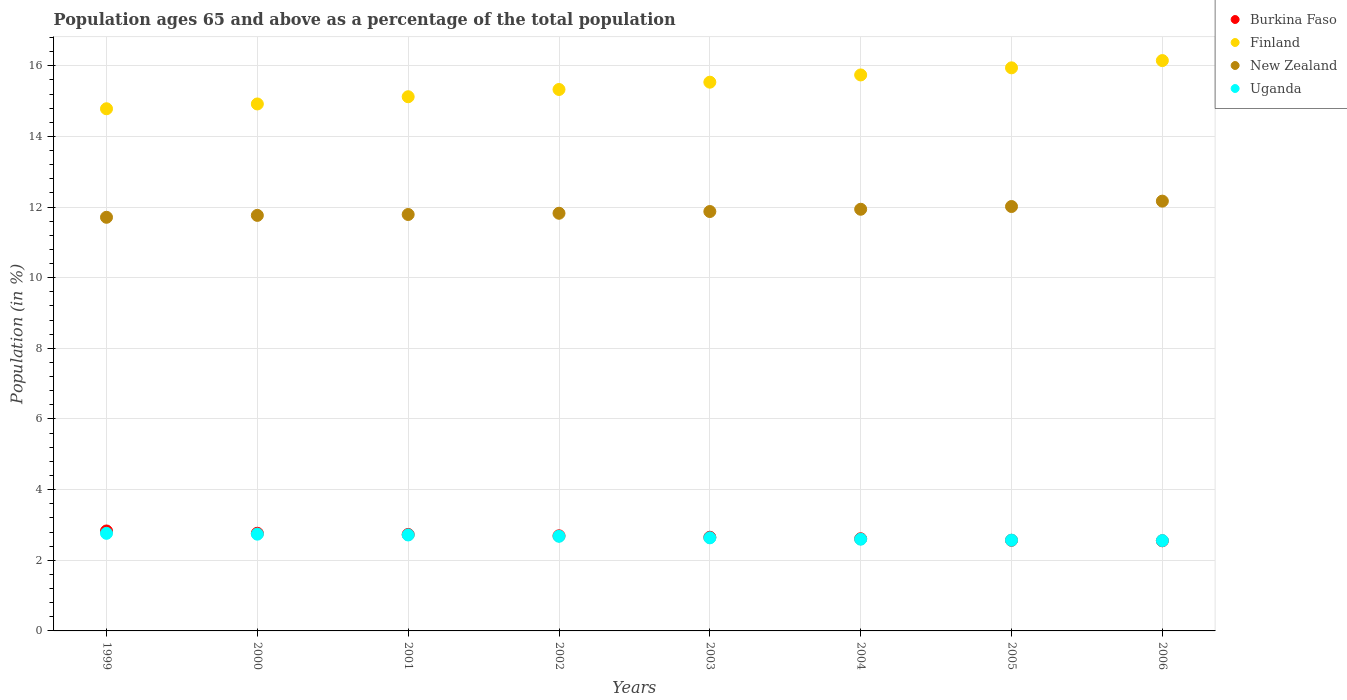How many different coloured dotlines are there?
Ensure brevity in your answer.  4. What is the percentage of the population ages 65 and above in Finland in 2003?
Make the answer very short. 15.54. Across all years, what is the maximum percentage of the population ages 65 and above in New Zealand?
Give a very brief answer. 12.17. Across all years, what is the minimum percentage of the population ages 65 and above in Burkina Faso?
Provide a succinct answer. 2.55. In which year was the percentage of the population ages 65 and above in Uganda maximum?
Keep it short and to the point. 1999. What is the total percentage of the population ages 65 and above in Burkina Faso in the graph?
Make the answer very short. 21.4. What is the difference between the percentage of the population ages 65 and above in New Zealand in 2002 and that in 2003?
Offer a very short reply. -0.05. What is the difference between the percentage of the population ages 65 and above in Burkina Faso in 1999 and the percentage of the population ages 65 and above in New Zealand in 2000?
Give a very brief answer. -8.93. What is the average percentage of the population ages 65 and above in Finland per year?
Provide a short and direct response. 15.44. In the year 2001, what is the difference between the percentage of the population ages 65 and above in Burkina Faso and percentage of the population ages 65 and above in Finland?
Provide a succinct answer. -12.39. In how many years, is the percentage of the population ages 65 and above in Finland greater than 7.2?
Offer a very short reply. 8. What is the ratio of the percentage of the population ages 65 and above in Finland in 2003 to that in 2006?
Keep it short and to the point. 0.96. Is the difference between the percentage of the population ages 65 and above in Burkina Faso in 2003 and 2005 greater than the difference between the percentage of the population ages 65 and above in Finland in 2003 and 2005?
Give a very brief answer. Yes. What is the difference between the highest and the second highest percentage of the population ages 65 and above in Finland?
Provide a succinct answer. 0.21. What is the difference between the highest and the lowest percentage of the population ages 65 and above in New Zealand?
Your response must be concise. 0.46. Is the sum of the percentage of the population ages 65 and above in Finland in 1999 and 2003 greater than the maximum percentage of the population ages 65 and above in New Zealand across all years?
Make the answer very short. Yes. Does the percentage of the population ages 65 and above in Finland monotonically increase over the years?
Your answer should be very brief. Yes. Is the percentage of the population ages 65 and above in New Zealand strictly less than the percentage of the population ages 65 and above in Uganda over the years?
Offer a very short reply. No. How many dotlines are there?
Provide a succinct answer. 4. Are the values on the major ticks of Y-axis written in scientific E-notation?
Keep it short and to the point. No. Does the graph contain grids?
Give a very brief answer. Yes. How many legend labels are there?
Provide a succinct answer. 4. What is the title of the graph?
Offer a terse response. Population ages 65 and above as a percentage of the total population. What is the Population (in %) of Burkina Faso in 1999?
Your answer should be very brief. 2.83. What is the Population (in %) of Finland in 1999?
Offer a terse response. 14.78. What is the Population (in %) in New Zealand in 1999?
Give a very brief answer. 11.71. What is the Population (in %) of Uganda in 1999?
Offer a terse response. 2.76. What is the Population (in %) of Burkina Faso in 2000?
Ensure brevity in your answer.  2.76. What is the Population (in %) of Finland in 2000?
Your response must be concise. 14.92. What is the Population (in %) of New Zealand in 2000?
Keep it short and to the point. 11.76. What is the Population (in %) of Uganda in 2000?
Your answer should be compact. 2.74. What is the Population (in %) in Burkina Faso in 2001?
Keep it short and to the point. 2.73. What is the Population (in %) in Finland in 2001?
Your response must be concise. 15.12. What is the Population (in %) of New Zealand in 2001?
Ensure brevity in your answer.  11.79. What is the Population (in %) in Uganda in 2001?
Make the answer very short. 2.72. What is the Population (in %) of Burkina Faso in 2002?
Offer a terse response. 2.69. What is the Population (in %) in Finland in 2002?
Keep it short and to the point. 15.33. What is the Population (in %) in New Zealand in 2002?
Offer a very short reply. 11.82. What is the Population (in %) of Uganda in 2002?
Keep it short and to the point. 2.68. What is the Population (in %) in Burkina Faso in 2003?
Your answer should be very brief. 2.65. What is the Population (in %) in Finland in 2003?
Offer a very short reply. 15.54. What is the Population (in %) in New Zealand in 2003?
Offer a very short reply. 11.87. What is the Population (in %) of Uganda in 2003?
Offer a very short reply. 2.64. What is the Population (in %) in Burkina Faso in 2004?
Provide a succinct answer. 2.61. What is the Population (in %) of Finland in 2004?
Provide a short and direct response. 15.74. What is the Population (in %) in New Zealand in 2004?
Give a very brief answer. 11.94. What is the Population (in %) of Uganda in 2004?
Your response must be concise. 2.6. What is the Population (in %) in Burkina Faso in 2005?
Ensure brevity in your answer.  2.57. What is the Population (in %) in Finland in 2005?
Keep it short and to the point. 15.94. What is the Population (in %) of New Zealand in 2005?
Your answer should be compact. 12.02. What is the Population (in %) of Uganda in 2005?
Keep it short and to the point. 2.57. What is the Population (in %) of Burkina Faso in 2006?
Give a very brief answer. 2.55. What is the Population (in %) of Finland in 2006?
Your answer should be compact. 16.15. What is the Population (in %) of New Zealand in 2006?
Provide a short and direct response. 12.17. What is the Population (in %) of Uganda in 2006?
Provide a succinct answer. 2.56. Across all years, what is the maximum Population (in %) of Burkina Faso?
Ensure brevity in your answer.  2.83. Across all years, what is the maximum Population (in %) in Finland?
Offer a very short reply. 16.15. Across all years, what is the maximum Population (in %) of New Zealand?
Make the answer very short. 12.17. Across all years, what is the maximum Population (in %) in Uganda?
Offer a terse response. 2.76. Across all years, what is the minimum Population (in %) of Burkina Faso?
Make the answer very short. 2.55. Across all years, what is the minimum Population (in %) in Finland?
Keep it short and to the point. 14.78. Across all years, what is the minimum Population (in %) of New Zealand?
Your answer should be compact. 11.71. Across all years, what is the minimum Population (in %) of Uganda?
Your answer should be very brief. 2.56. What is the total Population (in %) of Burkina Faso in the graph?
Offer a very short reply. 21.4. What is the total Population (in %) in Finland in the graph?
Your answer should be compact. 123.52. What is the total Population (in %) of New Zealand in the graph?
Your answer should be very brief. 95.08. What is the total Population (in %) of Uganda in the graph?
Give a very brief answer. 21.26. What is the difference between the Population (in %) in Burkina Faso in 1999 and that in 2000?
Your answer should be very brief. 0.06. What is the difference between the Population (in %) of Finland in 1999 and that in 2000?
Give a very brief answer. -0.14. What is the difference between the Population (in %) of New Zealand in 1999 and that in 2000?
Your answer should be compact. -0.05. What is the difference between the Population (in %) of Uganda in 1999 and that in 2000?
Keep it short and to the point. 0.02. What is the difference between the Population (in %) of Burkina Faso in 1999 and that in 2001?
Offer a terse response. 0.1. What is the difference between the Population (in %) of Finland in 1999 and that in 2001?
Offer a very short reply. -0.34. What is the difference between the Population (in %) of New Zealand in 1999 and that in 2001?
Ensure brevity in your answer.  -0.08. What is the difference between the Population (in %) of Uganda in 1999 and that in 2001?
Keep it short and to the point. 0.05. What is the difference between the Population (in %) in Burkina Faso in 1999 and that in 2002?
Offer a terse response. 0.14. What is the difference between the Population (in %) in Finland in 1999 and that in 2002?
Your answer should be very brief. -0.55. What is the difference between the Population (in %) in New Zealand in 1999 and that in 2002?
Ensure brevity in your answer.  -0.11. What is the difference between the Population (in %) of Uganda in 1999 and that in 2002?
Keep it short and to the point. 0.08. What is the difference between the Population (in %) in Burkina Faso in 1999 and that in 2003?
Provide a succinct answer. 0.18. What is the difference between the Population (in %) in Finland in 1999 and that in 2003?
Provide a short and direct response. -0.75. What is the difference between the Population (in %) of New Zealand in 1999 and that in 2003?
Ensure brevity in your answer.  -0.16. What is the difference between the Population (in %) in Uganda in 1999 and that in 2003?
Ensure brevity in your answer.  0.13. What is the difference between the Population (in %) of Burkina Faso in 1999 and that in 2004?
Keep it short and to the point. 0.22. What is the difference between the Population (in %) in Finland in 1999 and that in 2004?
Provide a short and direct response. -0.96. What is the difference between the Population (in %) in New Zealand in 1999 and that in 2004?
Keep it short and to the point. -0.23. What is the difference between the Population (in %) in Uganda in 1999 and that in 2004?
Your answer should be compact. 0.17. What is the difference between the Population (in %) of Burkina Faso in 1999 and that in 2005?
Make the answer very short. 0.26. What is the difference between the Population (in %) of Finland in 1999 and that in 2005?
Your response must be concise. -1.16. What is the difference between the Population (in %) in New Zealand in 1999 and that in 2005?
Make the answer very short. -0.3. What is the difference between the Population (in %) of Uganda in 1999 and that in 2005?
Your answer should be compact. 0.19. What is the difference between the Population (in %) of Burkina Faso in 1999 and that in 2006?
Your response must be concise. 0.28. What is the difference between the Population (in %) of Finland in 1999 and that in 2006?
Your response must be concise. -1.36. What is the difference between the Population (in %) of New Zealand in 1999 and that in 2006?
Provide a succinct answer. -0.46. What is the difference between the Population (in %) in Uganda in 1999 and that in 2006?
Offer a very short reply. 0.21. What is the difference between the Population (in %) of Burkina Faso in 2000 and that in 2001?
Offer a very short reply. 0.03. What is the difference between the Population (in %) of Finland in 2000 and that in 2001?
Your response must be concise. -0.2. What is the difference between the Population (in %) of New Zealand in 2000 and that in 2001?
Your response must be concise. -0.03. What is the difference between the Population (in %) of Uganda in 2000 and that in 2001?
Keep it short and to the point. 0.02. What is the difference between the Population (in %) of Burkina Faso in 2000 and that in 2002?
Your answer should be very brief. 0.07. What is the difference between the Population (in %) in Finland in 2000 and that in 2002?
Give a very brief answer. -0.41. What is the difference between the Population (in %) of New Zealand in 2000 and that in 2002?
Give a very brief answer. -0.06. What is the difference between the Population (in %) in Uganda in 2000 and that in 2002?
Keep it short and to the point. 0.06. What is the difference between the Population (in %) of Burkina Faso in 2000 and that in 2003?
Give a very brief answer. 0.11. What is the difference between the Population (in %) in Finland in 2000 and that in 2003?
Provide a short and direct response. -0.62. What is the difference between the Population (in %) in New Zealand in 2000 and that in 2003?
Make the answer very short. -0.11. What is the difference between the Population (in %) in Uganda in 2000 and that in 2003?
Your answer should be compact. 0.1. What is the difference between the Population (in %) of Burkina Faso in 2000 and that in 2004?
Keep it short and to the point. 0.16. What is the difference between the Population (in %) of Finland in 2000 and that in 2004?
Ensure brevity in your answer.  -0.82. What is the difference between the Population (in %) of New Zealand in 2000 and that in 2004?
Your answer should be very brief. -0.17. What is the difference between the Population (in %) of Uganda in 2000 and that in 2004?
Your response must be concise. 0.14. What is the difference between the Population (in %) in Burkina Faso in 2000 and that in 2005?
Provide a short and direct response. 0.2. What is the difference between the Population (in %) of Finland in 2000 and that in 2005?
Provide a succinct answer. -1.02. What is the difference between the Population (in %) of New Zealand in 2000 and that in 2005?
Ensure brevity in your answer.  -0.25. What is the difference between the Population (in %) in Uganda in 2000 and that in 2005?
Offer a very short reply. 0.17. What is the difference between the Population (in %) of Burkina Faso in 2000 and that in 2006?
Ensure brevity in your answer.  0.21. What is the difference between the Population (in %) in Finland in 2000 and that in 2006?
Offer a very short reply. -1.23. What is the difference between the Population (in %) of New Zealand in 2000 and that in 2006?
Offer a terse response. -0.4. What is the difference between the Population (in %) in Uganda in 2000 and that in 2006?
Offer a terse response. 0.18. What is the difference between the Population (in %) of Burkina Faso in 2001 and that in 2002?
Make the answer very short. 0.04. What is the difference between the Population (in %) of Finland in 2001 and that in 2002?
Your response must be concise. -0.21. What is the difference between the Population (in %) in New Zealand in 2001 and that in 2002?
Your answer should be very brief. -0.03. What is the difference between the Population (in %) of Uganda in 2001 and that in 2002?
Keep it short and to the point. 0.04. What is the difference between the Population (in %) in Burkina Faso in 2001 and that in 2003?
Make the answer very short. 0.08. What is the difference between the Population (in %) in Finland in 2001 and that in 2003?
Your answer should be very brief. -0.41. What is the difference between the Population (in %) of New Zealand in 2001 and that in 2003?
Offer a terse response. -0.08. What is the difference between the Population (in %) in Uganda in 2001 and that in 2003?
Your answer should be compact. 0.08. What is the difference between the Population (in %) in Burkina Faso in 2001 and that in 2004?
Offer a very short reply. 0.12. What is the difference between the Population (in %) in Finland in 2001 and that in 2004?
Your response must be concise. -0.62. What is the difference between the Population (in %) of New Zealand in 2001 and that in 2004?
Your answer should be very brief. -0.15. What is the difference between the Population (in %) in Uganda in 2001 and that in 2004?
Offer a very short reply. 0.12. What is the difference between the Population (in %) in Burkina Faso in 2001 and that in 2005?
Offer a very short reply. 0.16. What is the difference between the Population (in %) in Finland in 2001 and that in 2005?
Your answer should be very brief. -0.82. What is the difference between the Population (in %) of New Zealand in 2001 and that in 2005?
Keep it short and to the point. -0.23. What is the difference between the Population (in %) in Uganda in 2001 and that in 2005?
Give a very brief answer. 0.15. What is the difference between the Population (in %) in Burkina Faso in 2001 and that in 2006?
Your answer should be compact. 0.18. What is the difference between the Population (in %) of Finland in 2001 and that in 2006?
Your answer should be very brief. -1.02. What is the difference between the Population (in %) of New Zealand in 2001 and that in 2006?
Make the answer very short. -0.38. What is the difference between the Population (in %) of Uganda in 2001 and that in 2006?
Offer a very short reply. 0.16. What is the difference between the Population (in %) of Burkina Faso in 2002 and that in 2003?
Make the answer very short. 0.04. What is the difference between the Population (in %) in Finland in 2002 and that in 2003?
Make the answer very short. -0.21. What is the difference between the Population (in %) of New Zealand in 2002 and that in 2003?
Provide a succinct answer. -0.05. What is the difference between the Population (in %) in Uganda in 2002 and that in 2003?
Keep it short and to the point. 0.04. What is the difference between the Population (in %) in Burkina Faso in 2002 and that in 2004?
Your answer should be compact. 0.08. What is the difference between the Population (in %) in Finland in 2002 and that in 2004?
Your answer should be compact. -0.41. What is the difference between the Population (in %) in New Zealand in 2002 and that in 2004?
Your response must be concise. -0.11. What is the difference between the Population (in %) in Uganda in 2002 and that in 2004?
Provide a short and direct response. 0.08. What is the difference between the Population (in %) in Burkina Faso in 2002 and that in 2005?
Provide a short and direct response. 0.13. What is the difference between the Population (in %) in Finland in 2002 and that in 2005?
Your answer should be very brief. -0.61. What is the difference between the Population (in %) in New Zealand in 2002 and that in 2005?
Offer a very short reply. -0.19. What is the difference between the Population (in %) in Uganda in 2002 and that in 2005?
Your answer should be compact. 0.11. What is the difference between the Population (in %) in Burkina Faso in 2002 and that in 2006?
Offer a very short reply. 0.14. What is the difference between the Population (in %) in Finland in 2002 and that in 2006?
Give a very brief answer. -0.82. What is the difference between the Population (in %) of New Zealand in 2002 and that in 2006?
Provide a succinct answer. -0.34. What is the difference between the Population (in %) of Uganda in 2002 and that in 2006?
Your answer should be very brief. 0.12. What is the difference between the Population (in %) in Burkina Faso in 2003 and that in 2004?
Offer a terse response. 0.04. What is the difference between the Population (in %) in Finland in 2003 and that in 2004?
Offer a very short reply. -0.2. What is the difference between the Population (in %) in New Zealand in 2003 and that in 2004?
Your answer should be compact. -0.06. What is the difference between the Population (in %) in Uganda in 2003 and that in 2004?
Your answer should be very brief. 0.04. What is the difference between the Population (in %) of Burkina Faso in 2003 and that in 2005?
Provide a succinct answer. 0.09. What is the difference between the Population (in %) of Finland in 2003 and that in 2005?
Offer a terse response. -0.41. What is the difference between the Population (in %) in New Zealand in 2003 and that in 2005?
Your answer should be compact. -0.14. What is the difference between the Population (in %) of Uganda in 2003 and that in 2005?
Offer a very short reply. 0.07. What is the difference between the Population (in %) in Burkina Faso in 2003 and that in 2006?
Offer a very short reply. 0.1. What is the difference between the Population (in %) of Finland in 2003 and that in 2006?
Keep it short and to the point. -0.61. What is the difference between the Population (in %) in New Zealand in 2003 and that in 2006?
Your response must be concise. -0.29. What is the difference between the Population (in %) of Uganda in 2003 and that in 2006?
Offer a terse response. 0.08. What is the difference between the Population (in %) of Burkina Faso in 2004 and that in 2005?
Keep it short and to the point. 0.04. What is the difference between the Population (in %) in Finland in 2004 and that in 2005?
Keep it short and to the point. -0.2. What is the difference between the Population (in %) in New Zealand in 2004 and that in 2005?
Make the answer very short. -0.08. What is the difference between the Population (in %) of Uganda in 2004 and that in 2005?
Your answer should be very brief. 0.03. What is the difference between the Population (in %) of Burkina Faso in 2004 and that in 2006?
Offer a terse response. 0.06. What is the difference between the Population (in %) of Finland in 2004 and that in 2006?
Offer a very short reply. -0.41. What is the difference between the Population (in %) of New Zealand in 2004 and that in 2006?
Give a very brief answer. -0.23. What is the difference between the Population (in %) in Uganda in 2004 and that in 2006?
Make the answer very short. 0.04. What is the difference between the Population (in %) of Burkina Faso in 2005 and that in 2006?
Your answer should be compact. 0.01. What is the difference between the Population (in %) of Finland in 2005 and that in 2006?
Give a very brief answer. -0.21. What is the difference between the Population (in %) in New Zealand in 2005 and that in 2006?
Offer a very short reply. -0.15. What is the difference between the Population (in %) in Uganda in 2005 and that in 2006?
Your answer should be very brief. 0.01. What is the difference between the Population (in %) of Burkina Faso in 1999 and the Population (in %) of Finland in 2000?
Your answer should be compact. -12.09. What is the difference between the Population (in %) in Burkina Faso in 1999 and the Population (in %) in New Zealand in 2000?
Make the answer very short. -8.93. What is the difference between the Population (in %) of Burkina Faso in 1999 and the Population (in %) of Uganda in 2000?
Provide a succinct answer. 0.09. What is the difference between the Population (in %) in Finland in 1999 and the Population (in %) in New Zealand in 2000?
Your answer should be compact. 3.02. What is the difference between the Population (in %) of Finland in 1999 and the Population (in %) of Uganda in 2000?
Keep it short and to the point. 12.04. What is the difference between the Population (in %) in New Zealand in 1999 and the Population (in %) in Uganda in 2000?
Your answer should be very brief. 8.97. What is the difference between the Population (in %) of Burkina Faso in 1999 and the Population (in %) of Finland in 2001?
Your answer should be compact. -12.29. What is the difference between the Population (in %) of Burkina Faso in 1999 and the Population (in %) of New Zealand in 2001?
Provide a short and direct response. -8.96. What is the difference between the Population (in %) of Burkina Faso in 1999 and the Population (in %) of Uganda in 2001?
Give a very brief answer. 0.11. What is the difference between the Population (in %) in Finland in 1999 and the Population (in %) in New Zealand in 2001?
Your answer should be compact. 2.99. What is the difference between the Population (in %) of Finland in 1999 and the Population (in %) of Uganda in 2001?
Offer a terse response. 12.07. What is the difference between the Population (in %) in New Zealand in 1999 and the Population (in %) in Uganda in 2001?
Your response must be concise. 8.99. What is the difference between the Population (in %) in Burkina Faso in 1999 and the Population (in %) in Finland in 2002?
Provide a succinct answer. -12.5. What is the difference between the Population (in %) in Burkina Faso in 1999 and the Population (in %) in New Zealand in 2002?
Your response must be concise. -8.99. What is the difference between the Population (in %) in Burkina Faso in 1999 and the Population (in %) in Uganda in 2002?
Your answer should be very brief. 0.15. What is the difference between the Population (in %) of Finland in 1999 and the Population (in %) of New Zealand in 2002?
Make the answer very short. 2.96. What is the difference between the Population (in %) of Finland in 1999 and the Population (in %) of Uganda in 2002?
Offer a terse response. 12.1. What is the difference between the Population (in %) of New Zealand in 1999 and the Population (in %) of Uganda in 2002?
Offer a very short reply. 9.03. What is the difference between the Population (in %) in Burkina Faso in 1999 and the Population (in %) in Finland in 2003?
Provide a succinct answer. -12.71. What is the difference between the Population (in %) of Burkina Faso in 1999 and the Population (in %) of New Zealand in 2003?
Offer a terse response. -9.04. What is the difference between the Population (in %) of Burkina Faso in 1999 and the Population (in %) of Uganda in 2003?
Your response must be concise. 0.19. What is the difference between the Population (in %) in Finland in 1999 and the Population (in %) in New Zealand in 2003?
Offer a very short reply. 2.91. What is the difference between the Population (in %) of Finland in 1999 and the Population (in %) of Uganda in 2003?
Your answer should be compact. 12.15. What is the difference between the Population (in %) of New Zealand in 1999 and the Population (in %) of Uganda in 2003?
Ensure brevity in your answer.  9.07. What is the difference between the Population (in %) in Burkina Faso in 1999 and the Population (in %) in Finland in 2004?
Ensure brevity in your answer.  -12.91. What is the difference between the Population (in %) in Burkina Faso in 1999 and the Population (in %) in New Zealand in 2004?
Make the answer very short. -9.11. What is the difference between the Population (in %) of Burkina Faso in 1999 and the Population (in %) of Uganda in 2004?
Keep it short and to the point. 0.23. What is the difference between the Population (in %) of Finland in 1999 and the Population (in %) of New Zealand in 2004?
Ensure brevity in your answer.  2.85. What is the difference between the Population (in %) of Finland in 1999 and the Population (in %) of Uganda in 2004?
Keep it short and to the point. 12.19. What is the difference between the Population (in %) in New Zealand in 1999 and the Population (in %) in Uganda in 2004?
Provide a succinct answer. 9.11. What is the difference between the Population (in %) of Burkina Faso in 1999 and the Population (in %) of Finland in 2005?
Provide a succinct answer. -13.11. What is the difference between the Population (in %) of Burkina Faso in 1999 and the Population (in %) of New Zealand in 2005?
Keep it short and to the point. -9.19. What is the difference between the Population (in %) in Burkina Faso in 1999 and the Population (in %) in Uganda in 2005?
Offer a very short reply. 0.26. What is the difference between the Population (in %) of Finland in 1999 and the Population (in %) of New Zealand in 2005?
Offer a terse response. 2.77. What is the difference between the Population (in %) of Finland in 1999 and the Population (in %) of Uganda in 2005?
Keep it short and to the point. 12.21. What is the difference between the Population (in %) of New Zealand in 1999 and the Population (in %) of Uganda in 2005?
Keep it short and to the point. 9.14. What is the difference between the Population (in %) of Burkina Faso in 1999 and the Population (in %) of Finland in 2006?
Your answer should be very brief. -13.32. What is the difference between the Population (in %) of Burkina Faso in 1999 and the Population (in %) of New Zealand in 2006?
Your answer should be compact. -9.34. What is the difference between the Population (in %) in Burkina Faso in 1999 and the Population (in %) in Uganda in 2006?
Keep it short and to the point. 0.27. What is the difference between the Population (in %) in Finland in 1999 and the Population (in %) in New Zealand in 2006?
Keep it short and to the point. 2.62. What is the difference between the Population (in %) in Finland in 1999 and the Population (in %) in Uganda in 2006?
Provide a short and direct response. 12.23. What is the difference between the Population (in %) of New Zealand in 1999 and the Population (in %) of Uganda in 2006?
Your answer should be very brief. 9.15. What is the difference between the Population (in %) in Burkina Faso in 2000 and the Population (in %) in Finland in 2001?
Provide a short and direct response. -12.36. What is the difference between the Population (in %) of Burkina Faso in 2000 and the Population (in %) of New Zealand in 2001?
Your answer should be very brief. -9.02. What is the difference between the Population (in %) in Burkina Faso in 2000 and the Population (in %) in Uganda in 2001?
Keep it short and to the point. 0.05. What is the difference between the Population (in %) in Finland in 2000 and the Population (in %) in New Zealand in 2001?
Provide a short and direct response. 3.13. What is the difference between the Population (in %) of Finland in 2000 and the Population (in %) of Uganda in 2001?
Ensure brevity in your answer.  12.2. What is the difference between the Population (in %) in New Zealand in 2000 and the Population (in %) in Uganda in 2001?
Make the answer very short. 9.05. What is the difference between the Population (in %) in Burkina Faso in 2000 and the Population (in %) in Finland in 2002?
Your answer should be compact. -12.56. What is the difference between the Population (in %) in Burkina Faso in 2000 and the Population (in %) in New Zealand in 2002?
Make the answer very short. -9.06. What is the difference between the Population (in %) in Burkina Faso in 2000 and the Population (in %) in Uganda in 2002?
Provide a succinct answer. 0.09. What is the difference between the Population (in %) of Finland in 2000 and the Population (in %) of New Zealand in 2002?
Your answer should be compact. 3.09. What is the difference between the Population (in %) of Finland in 2000 and the Population (in %) of Uganda in 2002?
Your answer should be compact. 12.24. What is the difference between the Population (in %) of New Zealand in 2000 and the Population (in %) of Uganda in 2002?
Ensure brevity in your answer.  9.09. What is the difference between the Population (in %) of Burkina Faso in 2000 and the Population (in %) of Finland in 2003?
Offer a terse response. -12.77. What is the difference between the Population (in %) in Burkina Faso in 2000 and the Population (in %) in New Zealand in 2003?
Provide a succinct answer. -9.11. What is the difference between the Population (in %) of Burkina Faso in 2000 and the Population (in %) of Uganda in 2003?
Ensure brevity in your answer.  0.13. What is the difference between the Population (in %) of Finland in 2000 and the Population (in %) of New Zealand in 2003?
Offer a very short reply. 3.05. What is the difference between the Population (in %) in Finland in 2000 and the Population (in %) in Uganda in 2003?
Offer a terse response. 12.28. What is the difference between the Population (in %) in New Zealand in 2000 and the Population (in %) in Uganda in 2003?
Your answer should be compact. 9.13. What is the difference between the Population (in %) of Burkina Faso in 2000 and the Population (in %) of Finland in 2004?
Your answer should be compact. -12.98. What is the difference between the Population (in %) in Burkina Faso in 2000 and the Population (in %) in New Zealand in 2004?
Ensure brevity in your answer.  -9.17. What is the difference between the Population (in %) in Burkina Faso in 2000 and the Population (in %) in Uganda in 2004?
Ensure brevity in your answer.  0.17. What is the difference between the Population (in %) of Finland in 2000 and the Population (in %) of New Zealand in 2004?
Give a very brief answer. 2.98. What is the difference between the Population (in %) of Finland in 2000 and the Population (in %) of Uganda in 2004?
Offer a terse response. 12.32. What is the difference between the Population (in %) of New Zealand in 2000 and the Population (in %) of Uganda in 2004?
Provide a short and direct response. 9.17. What is the difference between the Population (in %) in Burkina Faso in 2000 and the Population (in %) in Finland in 2005?
Give a very brief answer. -13.18. What is the difference between the Population (in %) of Burkina Faso in 2000 and the Population (in %) of New Zealand in 2005?
Ensure brevity in your answer.  -9.25. What is the difference between the Population (in %) of Burkina Faso in 2000 and the Population (in %) of Uganda in 2005?
Provide a short and direct response. 0.2. What is the difference between the Population (in %) of Finland in 2000 and the Population (in %) of New Zealand in 2005?
Ensure brevity in your answer.  2.9. What is the difference between the Population (in %) of Finland in 2000 and the Population (in %) of Uganda in 2005?
Provide a succinct answer. 12.35. What is the difference between the Population (in %) of New Zealand in 2000 and the Population (in %) of Uganda in 2005?
Your answer should be very brief. 9.2. What is the difference between the Population (in %) in Burkina Faso in 2000 and the Population (in %) in Finland in 2006?
Ensure brevity in your answer.  -13.38. What is the difference between the Population (in %) of Burkina Faso in 2000 and the Population (in %) of New Zealand in 2006?
Make the answer very short. -9.4. What is the difference between the Population (in %) of Burkina Faso in 2000 and the Population (in %) of Uganda in 2006?
Provide a short and direct response. 0.21. What is the difference between the Population (in %) of Finland in 2000 and the Population (in %) of New Zealand in 2006?
Offer a very short reply. 2.75. What is the difference between the Population (in %) in Finland in 2000 and the Population (in %) in Uganda in 2006?
Make the answer very short. 12.36. What is the difference between the Population (in %) of New Zealand in 2000 and the Population (in %) of Uganda in 2006?
Offer a terse response. 9.21. What is the difference between the Population (in %) in Burkina Faso in 2001 and the Population (in %) in Finland in 2002?
Provide a short and direct response. -12.6. What is the difference between the Population (in %) of Burkina Faso in 2001 and the Population (in %) of New Zealand in 2002?
Offer a very short reply. -9.09. What is the difference between the Population (in %) of Burkina Faso in 2001 and the Population (in %) of Uganda in 2002?
Offer a very short reply. 0.05. What is the difference between the Population (in %) of Finland in 2001 and the Population (in %) of New Zealand in 2002?
Offer a very short reply. 3.3. What is the difference between the Population (in %) of Finland in 2001 and the Population (in %) of Uganda in 2002?
Keep it short and to the point. 12.44. What is the difference between the Population (in %) of New Zealand in 2001 and the Population (in %) of Uganda in 2002?
Offer a very short reply. 9.11. What is the difference between the Population (in %) in Burkina Faso in 2001 and the Population (in %) in Finland in 2003?
Give a very brief answer. -12.8. What is the difference between the Population (in %) of Burkina Faso in 2001 and the Population (in %) of New Zealand in 2003?
Your response must be concise. -9.14. What is the difference between the Population (in %) in Burkina Faso in 2001 and the Population (in %) in Uganda in 2003?
Provide a succinct answer. 0.1. What is the difference between the Population (in %) in Finland in 2001 and the Population (in %) in New Zealand in 2003?
Offer a terse response. 3.25. What is the difference between the Population (in %) in Finland in 2001 and the Population (in %) in Uganda in 2003?
Keep it short and to the point. 12.49. What is the difference between the Population (in %) in New Zealand in 2001 and the Population (in %) in Uganda in 2003?
Offer a terse response. 9.15. What is the difference between the Population (in %) in Burkina Faso in 2001 and the Population (in %) in Finland in 2004?
Your answer should be very brief. -13.01. What is the difference between the Population (in %) in Burkina Faso in 2001 and the Population (in %) in New Zealand in 2004?
Your response must be concise. -9.21. What is the difference between the Population (in %) in Burkina Faso in 2001 and the Population (in %) in Uganda in 2004?
Offer a terse response. 0.13. What is the difference between the Population (in %) of Finland in 2001 and the Population (in %) of New Zealand in 2004?
Your answer should be compact. 3.19. What is the difference between the Population (in %) of Finland in 2001 and the Population (in %) of Uganda in 2004?
Ensure brevity in your answer.  12.53. What is the difference between the Population (in %) of New Zealand in 2001 and the Population (in %) of Uganda in 2004?
Keep it short and to the point. 9.19. What is the difference between the Population (in %) of Burkina Faso in 2001 and the Population (in %) of Finland in 2005?
Offer a terse response. -13.21. What is the difference between the Population (in %) of Burkina Faso in 2001 and the Population (in %) of New Zealand in 2005?
Your answer should be compact. -9.28. What is the difference between the Population (in %) of Burkina Faso in 2001 and the Population (in %) of Uganda in 2005?
Your answer should be compact. 0.16. What is the difference between the Population (in %) of Finland in 2001 and the Population (in %) of New Zealand in 2005?
Provide a succinct answer. 3.11. What is the difference between the Population (in %) of Finland in 2001 and the Population (in %) of Uganda in 2005?
Give a very brief answer. 12.55. What is the difference between the Population (in %) of New Zealand in 2001 and the Population (in %) of Uganda in 2005?
Make the answer very short. 9.22. What is the difference between the Population (in %) in Burkina Faso in 2001 and the Population (in %) in Finland in 2006?
Offer a very short reply. -13.42. What is the difference between the Population (in %) in Burkina Faso in 2001 and the Population (in %) in New Zealand in 2006?
Offer a very short reply. -9.44. What is the difference between the Population (in %) of Burkina Faso in 2001 and the Population (in %) of Uganda in 2006?
Your response must be concise. 0.17. What is the difference between the Population (in %) in Finland in 2001 and the Population (in %) in New Zealand in 2006?
Make the answer very short. 2.96. What is the difference between the Population (in %) of Finland in 2001 and the Population (in %) of Uganda in 2006?
Offer a very short reply. 12.57. What is the difference between the Population (in %) in New Zealand in 2001 and the Population (in %) in Uganda in 2006?
Provide a succinct answer. 9.23. What is the difference between the Population (in %) of Burkina Faso in 2002 and the Population (in %) of Finland in 2003?
Your answer should be compact. -12.84. What is the difference between the Population (in %) in Burkina Faso in 2002 and the Population (in %) in New Zealand in 2003?
Offer a terse response. -9.18. What is the difference between the Population (in %) in Burkina Faso in 2002 and the Population (in %) in Uganda in 2003?
Your answer should be compact. 0.06. What is the difference between the Population (in %) of Finland in 2002 and the Population (in %) of New Zealand in 2003?
Make the answer very short. 3.45. What is the difference between the Population (in %) of Finland in 2002 and the Population (in %) of Uganda in 2003?
Your answer should be compact. 12.69. What is the difference between the Population (in %) in New Zealand in 2002 and the Population (in %) in Uganda in 2003?
Provide a short and direct response. 9.19. What is the difference between the Population (in %) in Burkina Faso in 2002 and the Population (in %) in Finland in 2004?
Your response must be concise. -13.05. What is the difference between the Population (in %) of Burkina Faso in 2002 and the Population (in %) of New Zealand in 2004?
Offer a terse response. -9.25. What is the difference between the Population (in %) in Burkina Faso in 2002 and the Population (in %) in Uganda in 2004?
Ensure brevity in your answer.  0.1. What is the difference between the Population (in %) of Finland in 2002 and the Population (in %) of New Zealand in 2004?
Offer a terse response. 3.39. What is the difference between the Population (in %) in Finland in 2002 and the Population (in %) in Uganda in 2004?
Offer a terse response. 12.73. What is the difference between the Population (in %) in New Zealand in 2002 and the Population (in %) in Uganda in 2004?
Offer a very short reply. 9.23. What is the difference between the Population (in %) in Burkina Faso in 2002 and the Population (in %) in Finland in 2005?
Offer a terse response. -13.25. What is the difference between the Population (in %) in Burkina Faso in 2002 and the Population (in %) in New Zealand in 2005?
Your answer should be very brief. -9.32. What is the difference between the Population (in %) of Burkina Faso in 2002 and the Population (in %) of Uganda in 2005?
Provide a succinct answer. 0.12. What is the difference between the Population (in %) in Finland in 2002 and the Population (in %) in New Zealand in 2005?
Make the answer very short. 3.31. What is the difference between the Population (in %) in Finland in 2002 and the Population (in %) in Uganda in 2005?
Offer a terse response. 12.76. What is the difference between the Population (in %) in New Zealand in 2002 and the Population (in %) in Uganda in 2005?
Offer a very short reply. 9.26. What is the difference between the Population (in %) of Burkina Faso in 2002 and the Population (in %) of Finland in 2006?
Ensure brevity in your answer.  -13.45. What is the difference between the Population (in %) in Burkina Faso in 2002 and the Population (in %) in New Zealand in 2006?
Your answer should be very brief. -9.48. What is the difference between the Population (in %) in Burkina Faso in 2002 and the Population (in %) in Uganda in 2006?
Offer a terse response. 0.14. What is the difference between the Population (in %) of Finland in 2002 and the Population (in %) of New Zealand in 2006?
Your response must be concise. 3.16. What is the difference between the Population (in %) of Finland in 2002 and the Population (in %) of Uganda in 2006?
Your response must be concise. 12.77. What is the difference between the Population (in %) of New Zealand in 2002 and the Population (in %) of Uganda in 2006?
Make the answer very short. 9.27. What is the difference between the Population (in %) of Burkina Faso in 2003 and the Population (in %) of Finland in 2004?
Provide a short and direct response. -13.09. What is the difference between the Population (in %) of Burkina Faso in 2003 and the Population (in %) of New Zealand in 2004?
Your response must be concise. -9.29. What is the difference between the Population (in %) in Burkina Faso in 2003 and the Population (in %) in Uganda in 2004?
Give a very brief answer. 0.05. What is the difference between the Population (in %) of Finland in 2003 and the Population (in %) of New Zealand in 2004?
Offer a terse response. 3.6. What is the difference between the Population (in %) of Finland in 2003 and the Population (in %) of Uganda in 2004?
Make the answer very short. 12.94. What is the difference between the Population (in %) of New Zealand in 2003 and the Population (in %) of Uganda in 2004?
Offer a very short reply. 9.28. What is the difference between the Population (in %) in Burkina Faso in 2003 and the Population (in %) in Finland in 2005?
Provide a short and direct response. -13.29. What is the difference between the Population (in %) of Burkina Faso in 2003 and the Population (in %) of New Zealand in 2005?
Offer a terse response. -9.36. What is the difference between the Population (in %) in Burkina Faso in 2003 and the Population (in %) in Uganda in 2005?
Offer a terse response. 0.08. What is the difference between the Population (in %) of Finland in 2003 and the Population (in %) of New Zealand in 2005?
Ensure brevity in your answer.  3.52. What is the difference between the Population (in %) in Finland in 2003 and the Population (in %) in Uganda in 2005?
Offer a terse response. 12.97. What is the difference between the Population (in %) of New Zealand in 2003 and the Population (in %) of Uganda in 2005?
Offer a terse response. 9.3. What is the difference between the Population (in %) of Burkina Faso in 2003 and the Population (in %) of Finland in 2006?
Your response must be concise. -13.49. What is the difference between the Population (in %) in Burkina Faso in 2003 and the Population (in %) in New Zealand in 2006?
Give a very brief answer. -9.52. What is the difference between the Population (in %) in Burkina Faso in 2003 and the Population (in %) in Uganda in 2006?
Your response must be concise. 0.09. What is the difference between the Population (in %) of Finland in 2003 and the Population (in %) of New Zealand in 2006?
Offer a very short reply. 3.37. What is the difference between the Population (in %) in Finland in 2003 and the Population (in %) in Uganda in 2006?
Your answer should be compact. 12.98. What is the difference between the Population (in %) of New Zealand in 2003 and the Population (in %) of Uganda in 2006?
Give a very brief answer. 9.32. What is the difference between the Population (in %) of Burkina Faso in 2004 and the Population (in %) of Finland in 2005?
Your answer should be very brief. -13.33. What is the difference between the Population (in %) in Burkina Faso in 2004 and the Population (in %) in New Zealand in 2005?
Ensure brevity in your answer.  -9.41. What is the difference between the Population (in %) of Burkina Faso in 2004 and the Population (in %) of Uganda in 2005?
Give a very brief answer. 0.04. What is the difference between the Population (in %) of Finland in 2004 and the Population (in %) of New Zealand in 2005?
Provide a succinct answer. 3.73. What is the difference between the Population (in %) of Finland in 2004 and the Population (in %) of Uganda in 2005?
Make the answer very short. 13.17. What is the difference between the Population (in %) of New Zealand in 2004 and the Population (in %) of Uganda in 2005?
Make the answer very short. 9.37. What is the difference between the Population (in %) of Burkina Faso in 2004 and the Population (in %) of Finland in 2006?
Your response must be concise. -13.54. What is the difference between the Population (in %) in Burkina Faso in 2004 and the Population (in %) in New Zealand in 2006?
Offer a very short reply. -9.56. What is the difference between the Population (in %) of Burkina Faso in 2004 and the Population (in %) of Uganda in 2006?
Your answer should be compact. 0.05. What is the difference between the Population (in %) in Finland in 2004 and the Population (in %) in New Zealand in 2006?
Ensure brevity in your answer.  3.57. What is the difference between the Population (in %) of Finland in 2004 and the Population (in %) of Uganda in 2006?
Keep it short and to the point. 13.18. What is the difference between the Population (in %) in New Zealand in 2004 and the Population (in %) in Uganda in 2006?
Make the answer very short. 9.38. What is the difference between the Population (in %) of Burkina Faso in 2005 and the Population (in %) of Finland in 2006?
Provide a short and direct response. -13.58. What is the difference between the Population (in %) of Burkina Faso in 2005 and the Population (in %) of New Zealand in 2006?
Your answer should be very brief. -9.6. What is the difference between the Population (in %) in Burkina Faso in 2005 and the Population (in %) in Uganda in 2006?
Ensure brevity in your answer.  0.01. What is the difference between the Population (in %) of Finland in 2005 and the Population (in %) of New Zealand in 2006?
Ensure brevity in your answer.  3.77. What is the difference between the Population (in %) in Finland in 2005 and the Population (in %) in Uganda in 2006?
Provide a succinct answer. 13.38. What is the difference between the Population (in %) of New Zealand in 2005 and the Population (in %) of Uganda in 2006?
Offer a very short reply. 9.46. What is the average Population (in %) of Burkina Faso per year?
Provide a short and direct response. 2.67. What is the average Population (in %) of Finland per year?
Your answer should be compact. 15.44. What is the average Population (in %) in New Zealand per year?
Your response must be concise. 11.89. What is the average Population (in %) in Uganda per year?
Make the answer very short. 2.66. In the year 1999, what is the difference between the Population (in %) of Burkina Faso and Population (in %) of Finland?
Provide a succinct answer. -11.95. In the year 1999, what is the difference between the Population (in %) of Burkina Faso and Population (in %) of New Zealand?
Provide a succinct answer. -8.88. In the year 1999, what is the difference between the Population (in %) of Burkina Faso and Population (in %) of Uganda?
Make the answer very short. 0.07. In the year 1999, what is the difference between the Population (in %) of Finland and Population (in %) of New Zealand?
Your answer should be very brief. 3.07. In the year 1999, what is the difference between the Population (in %) in Finland and Population (in %) in Uganda?
Your answer should be very brief. 12.02. In the year 1999, what is the difference between the Population (in %) of New Zealand and Population (in %) of Uganda?
Offer a very short reply. 8.95. In the year 2000, what is the difference between the Population (in %) of Burkina Faso and Population (in %) of Finland?
Give a very brief answer. -12.15. In the year 2000, what is the difference between the Population (in %) of Burkina Faso and Population (in %) of New Zealand?
Make the answer very short. -9. In the year 2000, what is the difference between the Population (in %) of Burkina Faso and Population (in %) of Uganda?
Your answer should be compact. 0.03. In the year 2000, what is the difference between the Population (in %) of Finland and Population (in %) of New Zealand?
Ensure brevity in your answer.  3.15. In the year 2000, what is the difference between the Population (in %) of Finland and Population (in %) of Uganda?
Ensure brevity in your answer.  12.18. In the year 2000, what is the difference between the Population (in %) of New Zealand and Population (in %) of Uganda?
Offer a terse response. 9.03. In the year 2001, what is the difference between the Population (in %) in Burkina Faso and Population (in %) in Finland?
Make the answer very short. -12.39. In the year 2001, what is the difference between the Population (in %) in Burkina Faso and Population (in %) in New Zealand?
Provide a succinct answer. -9.06. In the year 2001, what is the difference between the Population (in %) in Burkina Faso and Population (in %) in Uganda?
Provide a short and direct response. 0.01. In the year 2001, what is the difference between the Population (in %) in Finland and Population (in %) in New Zealand?
Offer a very short reply. 3.33. In the year 2001, what is the difference between the Population (in %) of Finland and Population (in %) of Uganda?
Your answer should be compact. 12.41. In the year 2001, what is the difference between the Population (in %) in New Zealand and Population (in %) in Uganda?
Offer a terse response. 9.07. In the year 2002, what is the difference between the Population (in %) in Burkina Faso and Population (in %) in Finland?
Your answer should be compact. -12.64. In the year 2002, what is the difference between the Population (in %) in Burkina Faso and Population (in %) in New Zealand?
Provide a short and direct response. -9.13. In the year 2002, what is the difference between the Population (in %) of Burkina Faso and Population (in %) of Uganda?
Your answer should be compact. 0.01. In the year 2002, what is the difference between the Population (in %) in Finland and Population (in %) in New Zealand?
Make the answer very short. 3.5. In the year 2002, what is the difference between the Population (in %) in Finland and Population (in %) in Uganda?
Keep it short and to the point. 12.65. In the year 2002, what is the difference between the Population (in %) of New Zealand and Population (in %) of Uganda?
Make the answer very short. 9.15. In the year 2003, what is the difference between the Population (in %) of Burkina Faso and Population (in %) of Finland?
Keep it short and to the point. -12.88. In the year 2003, what is the difference between the Population (in %) in Burkina Faso and Population (in %) in New Zealand?
Your answer should be compact. -9.22. In the year 2003, what is the difference between the Population (in %) in Burkina Faso and Population (in %) in Uganda?
Give a very brief answer. 0.02. In the year 2003, what is the difference between the Population (in %) in Finland and Population (in %) in New Zealand?
Your answer should be compact. 3.66. In the year 2003, what is the difference between the Population (in %) of Finland and Population (in %) of Uganda?
Your answer should be compact. 12.9. In the year 2003, what is the difference between the Population (in %) of New Zealand and Population (in %) of Uganda?
Make the answer very short. 9.24. In the year 2004, what is the difference between the Population (in %) of Burkina Faso and Population (in %) of Finland?
Offer a terse response. -13.13. In the year 2004, what is the difference between the Population (in %) of Burkina Faso and Population (in %) of New Zealand?
Give a very brief answer. -9.33. In the year 2004, what is the difference between the Population (in %) in Burkina Faso and Population (in %) in Uganda?
Your response must be concise. 0.01. In the year 2004, what is the difference between the Population (in %) of Finland and Population (in %) of New Zealand?
Your answer should be very brief. 3.8. In the year 2004, what is the difference between the Population (in %) of Finland and Population (in %) of Uganda?
Ensure brevity in your answer.  13.14. In the year 2004, what is the difference between the Population (in %) of New Zealand and Population (in %) of Uganda?
Your answer should be very brief. 9.34. In the year 2005, what is the difference between the Population (in %) in Burkina Faso and Population (in %) in Finland?
Offer a very short reply. -13.38. In the year 2005, what is the difference between the Population (in %) of Burkina Faso and Population (in %) of New Zealand?
Your answer should be compact. -9.45. In the year 2005, what is the difference between the Population (in %) in Burkina Faso and Population (in %) in Uganda?
Your response must be concise. -0. In the year 2005, what is the difference between the Population (in %) in Finland and Population (in %) in New Zealand?
Give a very brief answer. 3.93. In the year 2005, what is the difference between the Population (in %) in Finland and Population (in %) in Uganda?
Make the answer very short. 13.37. In the year 2005, what is the difference between the Population (in %) of New Zealand and Population (in %) of Uganda?
Your response must be concise. 9.45. In the year 2006, what is the difference between the Population (in %) of Burkina Faso and Population (in %) of Finland?
Provide a short and direct response. -13.59. In the year 2006, what is the difference between the Population (in %) in Burkina Faso and Population (in %) in New Zealand?
Ensure brevity in your answer.  -9.62. In the year 2006, what is the difference between the Population (in %) of Burkina Faso and Population (in %) of Uganda?
Keep it short and to the point. -0. In the year 2006, what is the difference between the Population (in %) in Finland and Population (in %) in New Zealand?
Offer a terse response. 3.98. In the year 2006, what is the difference between the Population (in %) of Finland and Population (in %) of Uganda?
Your answer should be compact. 13.59. In the year 2006, what is the difference between the Population (in %) of New Zealand and Population (in %) of Uganda?
Offer a very short reply. 9.61. What is the ratio of the Population (in %) in Burkina Faso in 1999 to that in 2000?
Make the answer very short. 1.02. What is the ratio of the Population (in %) of Finland in 1999 to that in 2000?
Your answer should be very brief. 0.99. What is the ratio of the Population (in %) of New Zealand in 1999 to that in 2000?
Your answer should be compact. 1. What is the ratio of the Population (in %) of Uganda in 1999 to that in 2000?
Provide a short and direct response. 1.01. What is the ratio of the Population (in %) of Burkina Faso in 1999 to that in 2001?
Provide a short and direct response. 1.04. What is the ratio of the Population (in %) in Finland in 1999 to that in 2001?
Keep it short and to the point. 0.98. What is the ratio of the Population (in %) in Burkina Faso in 1999 to that in 2002?
Your answer should be compact. 1.05. What is the ratio of the Population (in %) of Finland in 1999 to that in 2002?
Make the answer very short. 0.96. What is the ratio of the Population (in %) in Uganda in 1999 to that in 2002?
Make the answer very short. 1.03. What is the ratio of the Population (in %) in Burkina Faso in 1999 to that in 2003?
Keep it short and to the point. 1.07. What is the ratio of the Population (in %) in Finland in 1999 to that in 2003?
Ensure brevity in your answer.  0.95. What is the ratio of the Population (in %) in New Zealand in 1999 to that in 2003?
Ensure brevity in your answer.  0.99. What is the ratio of the Population (in %) in Uganda in 1999 to that in 2003?
Ensure brevity in your answer.  1.05. What is the ratio of the Population (in %) in Burkina Faso in 1999 to that in 2004?
Provide a succinct answer. 1.08. What is the ratio of the Population (in %) of Finland in 1999 to that in 2004?
Give a very brief answer. 0.94. What is the ratio of the Population (in %) of New Zealand in 1999 to that in 2004?
Provide a short and direct response. 0.98. What is the ratio of the Population (in %) in Uganda in 1999 to that in 2004?
Give a very brief answer. 1.06. What is the ratio of the Population (in %) of Burkina Faso in 1999 to that in 2005?
Your answer should be compact. 1.1. What is the ratio of the Population (in %) in Finland in 1999 to that in 2005?
Your response must be concise. 0.93. What is the ratio of the Population (in %) of New Zealand in 1999 to that in 2005?
Keep it short and to the point. 0.97. What is the ratio of the Population (in %) of Uganda in 1999 to that in 2005?
Ensure brevity in your answer.  1.08. What is the ratio of the Population (in %) in Burkina Faso in 1999 to that in 2006?
Offer a very short reply. 1.11. What is the ratio of the Population (in %) in Finland in 1999 to that in 2006?
Offer a very short reply. 0.92. What is the ratio of the Population (in %) of New Zealand in 1999 to that in 2006?
Ensure brevity in your answer.  0.96. What is the ratio of the Population (in %) of Uganda in 1999 to that in 2006?
Make the answer very short. 1.08. What is the ratio of the Population (in %) of Burkina Faso in 2000 to that in 2001?
Your answer should be compact. 1.01. What is the ratio of the Population (in %) in Finland in 2000 to that in 2001?
Offer a very short reply. 0.99. What is the ratio of the Population (in %) of New Zealand in 2000 to that in 2001?
Provide a succinct answer. 1. What is the ratio of the Population (in %) of Uganda in 2000 to that in 2001?
Your answer should be very brief. 1.01. What is the ratio of the Population (in %) of Burkina Faso in 2000 to that in 2002?
Your answer should be compact. 1.03. What is the ratio of the Population (in %) of Finland in 2000 to that in 2002?
Offer a very short reply. 0.97. What is the ratio of the Population (in %) of New Zealand in 2000 to that in 2002?
Provide a short and direct response. 0.99. What is the ratio of the Population (in %) in Uganda in 2000 to that in 2002?
Offer a terse response. 1.02. What is the ratio of the Population (in %) of Burkina Faso in 2000 to that in 2003?
Offer a terse response. 1.04. What is the ratio of the Population (in %) of Finland in 2000 to that in 2003?
Your response must be concise. 0.96. What is the ratio of the Population (in %) of New Zealand in 2000 to that in 2003?
Give a very brief answer. 0.99. What is the ratio of the Population (in %) in Uganda in 2000 to that in 2003?
Make the answer very short. 1.04. What is the ratio of the Population (in %) in Burkina Faso in 2000 to that in 2004?
Provide a short and direct response. 1.06. What is the ratio of the Population (in %) in Finland in 2000 to that in 2004?
Give a very brief answer. 0.95. What is the ratio of the Population (in %) in New Zealand in 2000 to that in 2004?
Give a very brief answer. 0.99. What is the ratio of the Population (in %) of Uganda in 2000 to that in 2004?
Give a very brief answer. 1.05. What is the ratio of the Population (in %) of Burkina Faso in 2000 to that in 2005?
Your answer should be very brief. 1.08. What is the ratio of the Population (in %) in Finland in 2000 to that in 2005?
Make the answer very short. 0.94. What is the ratio of the Population (in %) in New Zealand in 2000 to that in 2005?
Offer a very short reply. 0.98. What is the ratio of the Population (in %) of Uganda in 2000 to that in 2005?
Your answer should be compact. 1.07. What is the ratio of the Population (in %) in Burkina Faso in 2000 to that in 2006?
Make the answer very short. 1.08. What is the ratio of the Population (in %) in Finland in 2000 to that in 2006?
Your response must be concise. 0.92. What is the ratio of the Population (in %) of New Zealand in 2000 to that in 2006?
Your response must be concise. 0.97. What is the ratio of the Population (in %) of Uganda in 2000 to that in 2006?
Ensure brevity in your answer.  1.07. What is the ratio of the Population (in %) of Burkina Faso in 2001 to that in 2002?
Keep it short and to the point. 1.01. What is the ratio of the Population (in %) in Finland in 2001 to that in 2002?
Offer a very short reply. 0.99. What is the ratio of the Population (in %) in Uganda in 2001 to that in 2002?
Keep it short and to the point. 1.01. What is the ratio of the Population (in %) in Burkina Faso in 2001 to that in 2003?
Offer a terse response. 1.03. What is the ratio of the Population (in %) of Finland in 2001 to that in 2003?
Your response must be concise. 0.97. What is the ratio of the Population (in %) of New Zealand in 2001 to that in 2003?
Ensure brevity in your answer.  0.99. What is the ratio of the Population (in %) of Uganda in 2001 to that in 2003?
Your answer should be very brief. 1.03. What is the ratio of the Population (in %) in Burkina Faso in 2001 to that in 2004?
Ensure brevity in your answer.  1.05. What is the ratio of the Population (in %) of Finland in 2001 to that in 2004?
Give a very brief answer. 0.96. What is the ratio of the Population (in %) of New Zealand in 2001 to that in 2004?
Your answer should be very brief. 0.99. What is the ratio of the Population (in %) of Uganda in 2001 to that in 2004?
Your response must be concise. 1.05. What is the ratio of the Population (in %) of Burkina Faso in 2001 to that in 2005?
Your answer should be very brief. 1.06. What is the ratio of the Population (in %) of Finland in 2001 to that in 2005?
Your answer should be very brief. 0.95. What is the ratio of the Population (in %) in New Zealand in 2001 to that in 2005?
Provide a succinct answer. 0.98. What is the ratio of the Population (in %) of Uganda in 2001 to that in 2005?
Keep it short and to the point. 1.06. What is the ratio of the Population (in %) of Burkina Faso in 2001 to that in 2006?
Your response must be concise. 1.07. What is the ratio of the Population (in %) in Finland in 2001 to that in 2006?
Your answer should be compact. 0.94. What is the ratio of the Population (in %) in New Zealand in 2001 to that in 2006?
Make the answer very short. 0.97. What is the ratio of the Population (in %) of Uganda in 2001 to that in 2006?
Your answer should be very brief. 1.06. What is the ratio of the Population (in %) in Burkina Faso in 2002 to that in 2003?
Provide a succinct answer. 1.02. What is the ratio of the Population (in %) in Finland in 2002 to that in 2003?
Keep it short and to the point. 0.99. What is the ratio of the Population (in %) in New Zealand in 2002 to that in 2003?
Offer a very short reply. 1. What is the ratio of the Population (in %) in Uganda in 2002 to that in 2003?
Your answer should be very brief. 1.02. What is the ratio of the Population (in %) in Burkina Faso in 2002 to that in 2004?
Ensure brevity in your answer.  1.03. What is the ratio of the Population (in %) in Finland in 2002 to that in 2004?
Offer a very short reply. 0.97. What is the ratio of the Population (in %) of New Zealand in 2002 to that in 2004?
Give a very brief answer. 0.99. What is the ratio of the Population (in %) in Uganda in 2002 to that in 2004?
Keep it short and to the point. 1.03. What is the ratio of the Population (in %) in Burkina Faso in 2002 to that in 2005?
Your answer should be very brief. 1.05. What is the ratio of the Population (in %) of Finland in 2002 to that in 2005?
Offer a very short reply. 0.96. What is the ratio of the Population (in %) of New Zealand in 2002 to that in 2005?
Your answer should be compact. 0.98. What is the ratio of the Population (in %) in Uganda in 2002 to that in 2005?
Provide a short and direct response. 1.04. What is the ratio of the Population (in %) of Burkina Faso in 2002 to that in 2006?
Provide a succinct answer. 1.05. What is the ratio of the Population (in %) in Finland in 2002 to that in 2006?
Your response must be concise. 0.95. What is the ratio of the Population (in %) of New Zealand in 2002 to that in 2006?
Offer a terse response. 0.97. What is the ratio of the Population (in %) of Uganda in 2002 to that in 2006?
Make the answer very short. 1.05. What is the ratio of the Population (in %) of Burkina Faso in 2003 to that in 2004?
Offer a very short reply. 1.02. What is the ratio of the Population (in %) in Uganda in 2003 to that in 2004?
Offer a very short reply. 1.01. What is the ratio of the Population (in %) in Burkina Faso in 2003 to that in 2005?
Offer a very short reply. 1.03. What is the ratio of the Population (in %) of Finland in 2003 to that in 2005?
Your response must be concise. 0.97. What is the ratio of the Population (in %) in New Zealand in 2003 to that in 2005?
Provide a short and direct response. 0.99. What is the ratio of the Population (in %) of Uganda in 2003 to that in 2005?
Keep it short and to the point. 1.03. What is the ratio of the Population (in %) of Burkina Faso in 2003 to that in 2006?
Keep it short and to the point. 1.04. What is the ratio of the Population (in %) in Finland in 2003 to that in 2006?
Make the answer very short. 0.96. What is the ratio of the Population (in %) of New Zealand in 2003 to that in 2006?
Your response must be concise. 0.98. What is the ratio of the Population (in %) of Uganda in 2003 to that in 2006?
Your answer should be compact. 1.03. What is the ratio of the Population (in %) of Burkina Faso in 2004 to that in 2005?
Offer a very short reply. 1.02. What is the ratio of the Population (in %) of Finland in 2004 to that in 2005?
Give a very brief answer. 0.99. What is the ratio of the Population (in %) in New Zealand in 2004 to that in 2005?
Give a very brief answer. 0.99. What is the ratio of the Population (in %) in Uganda in 2004 to that in 2005?
Your answer should be very brief. 1.01. What is the ratio of the Population (in %) of Burkina Faso in 2004 to that in 2006?
Ensure brevity in your answer.  1.02. What is the ratio of the Population (in %) in Finland in 2004 to that in 2006?
Give a very brief answer. 0.97. What is the ratio of the Population (in %) of New Zealand in 2004 to that in 2006?
Provide a short and direct response. 0.98. What is the ratio of the Population (in %) of Uganda in 2004 to that in 2006?
Offer a terse response. 1.02. What is the ratio of the Population (in %) of Burkina Faso in 2005 to that in 2006?
Keep it short and to the point. 1.01. What is the ratio of the Population (in %) in Finland in 2005 to that in 2006?
Your answer should be compact. 0.99. What is the ratio of the Population (in %) in New Zealand in 2005 to that in 2006?
Ensure brevity in your answer.  0.99. What is the ratio of the Population (in %) in Uganda in 2005 to that in 2006?
Your response must be concise. 1. What is the difference between the highest and the second highest Population (in %) of Burkina Faso?
Offer a terse response. 0.06. What is the difference between the highest and the second highest Population (in %) in Finland?
Ensure brevity in your answer.  0.21. What is the difference between the highest and the second highest Population (in %) of New Zealand?
Your answer should be compact. 0.15. What is the difference between the highest and the second highest Population (in %) in Uganda?
Provide a succinct answer. 0.02. What is the difference between the highest and the lowest Population (in %) in Burkina Faso?
Ensure brevity in your answer.  0.28. What is the difference between the highest and the lowest Population (in %) of Finland?
Provide a short and direct response. 1.36. What is the difference between the highest and the lowest Population (in %) in New Zealand?
Your response must be concise. 0.46. What is the difference between the highest and the lowest Population (in %) in Uganda?
Provide a succinct answer. 0.21. 